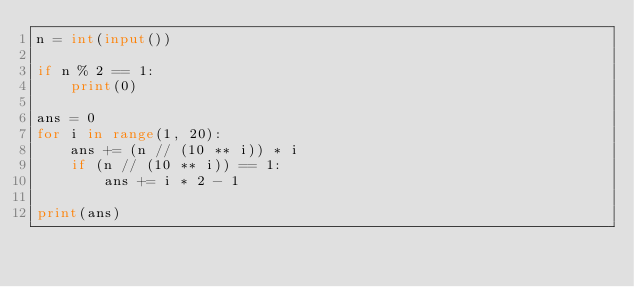Convert code to text. <code><loc_0><loc_0><loc_500><loc_500><_Python_>n = int(input())

if n % 2 == 1:
    print(0)

ans = 0
for i in range(1, 20):
    ans += (n // (10 ** i)) * i
    if (n // (10 ** i)) == 1:
        ans += i * 2 - 1

print(ans)</code> 